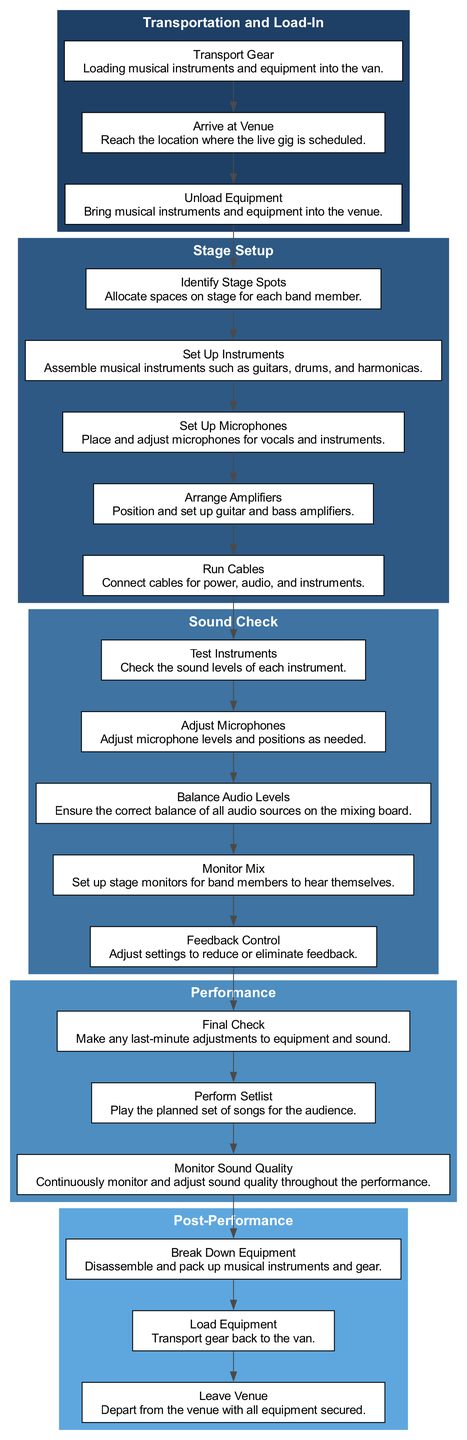What is the first step in the Equipment Setup Workflow? The first step in the workflow is "Transportation and Load-In." This is identified as the first element in the overall structure of the diagram, indicating the starting point of the process.
Answer: Transportation and Load-In How many stages are in the Equipment Setup Workflow? There are four stages represented in the diagram: Transportation and Load-In, Stage Setup, Sound Check, Performance, and Post-Performance. By counting the clusters, we find a total of five.
Answer: Five What is the last task in the Post-Performance stage? The task "Leave Venue" is identified as the last element of the Post-Performance stage in the diagram, indicating the final action to be done after packing up.
Answer: Leave Venue What are the three elements of the Sound Check stage? The three elements listed in the Sound Check stage are: "Test Instruments," "Adjust Microphones," and "Balance Audio Levels." These are specifically mentioned under this stage, showing their importance in preparing for the performance.
Answer: Test Instruments, Adjust Microphones, Balance Audio Levels What is the relationship between "Set Up Microphones" and "Balance Audio Levels"? "Set Up Microphones" precedes "Balance Audio Levels" in the diagram, indicating that microphones need to be set up and adjusted before balancing audio levels on the mixing board, demonstrating the sequence of tasks in the Sound Check stage.
Answer: Set Up Microphones → Balance Audio Levels How many elements are in the Stage Setup stage? There are five elements within the Stage Setup stage listed in the diagram: "Identify Stage Spots," "Set Up Instruments," "Set Up Microphones," "Arrange Amplifiers," and "Run Cables." A careful count of these items confirms the total.
Answer: Five What task follows "Perform Setlist"? The task "Monitor Sound Quality" follows "Perform Setlist" in the Performance stage, suggesting that monitoring occurs continuously after the performance begins to ensure sound quality stays optimal through the event.
Answer: Monitor Sound Quality What is the main purpose of the Sound Check stage? The main purpose of the Sound Check stage is to ensure that all audio sources are correctly balanced and set up before the actual performance, which is a crucial step for delivering good sound quality. Therefore, it holds multiple tasks all aimed at achieving this goal.
Answer: Ensure correct audio balance What is an example of a task that occurs during the Stage Setup? An example of a task that occurs during Stage Setup is "Run Cables." This task is significant as it involves connecting all the necessary power and audio connections required for the performance.
Answer: Run Cables 